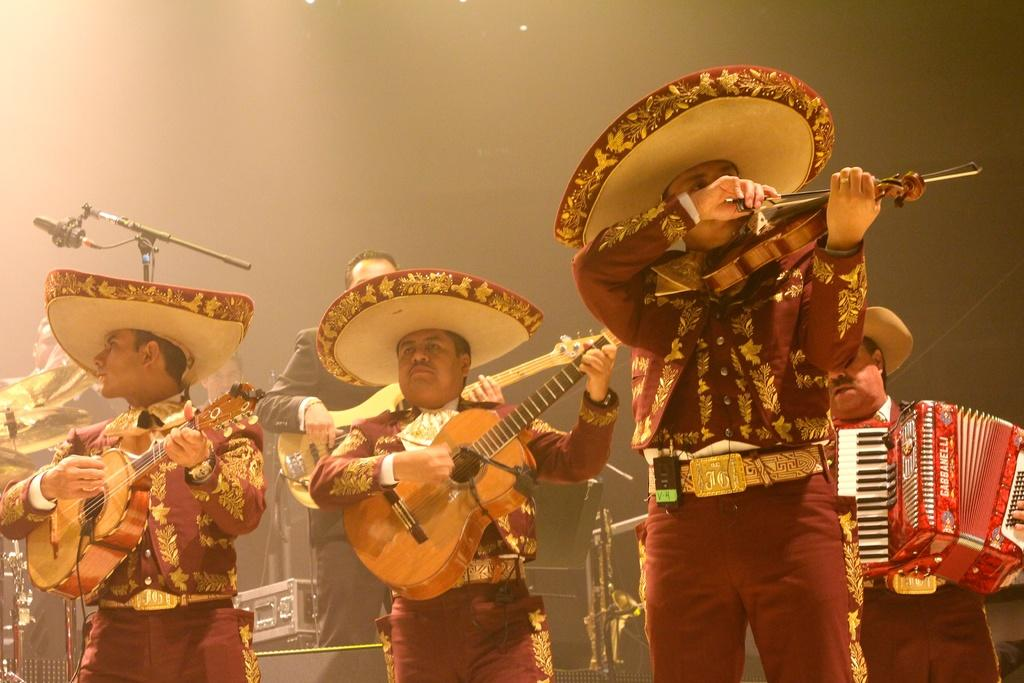How many people are in the image? There are three persons in the image. What are the people in the image holding? Each person is holding a musical instrument, either a guitar or a violin. What are the people wearing? The persons are wearing red dresses and hats. What else can be seen in the image? There is a box in the image. What is happening in the background of the image? Other persons are playing musical instruments in the background. How does the comparison between the sack and the instruments help the performance in the image? There is no sack present in the image, so it cannot be compared to the instruments or contribute to the performance. 